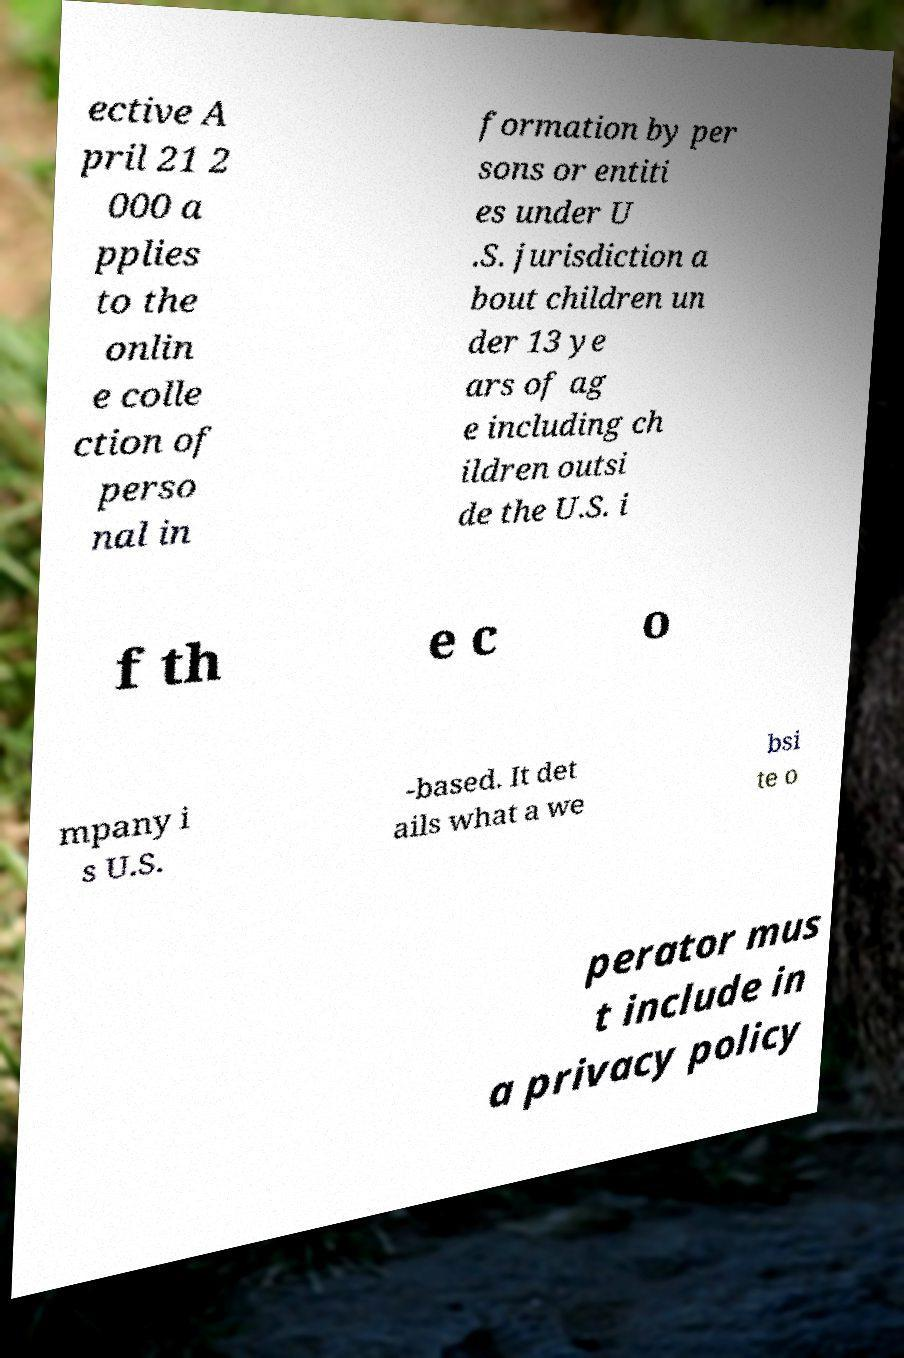Could you assist in decoding the text presented in this image and type it out clearly? ective A pril 21 2 000 a pplies to the onlin e colle ction of perso nal in formation by per sons or entiti es under U .S. jurisdiction a bout children un der 13 ye ars of ag e including ch ildren outsi de the U.S. i f th e c o mpany i s U.S. -based. It det ails what a we bsi te o perator mus t include in a privacy policy 